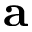<formula> <loc_0><loc_0><loc_500><loc_500>a</formula> 